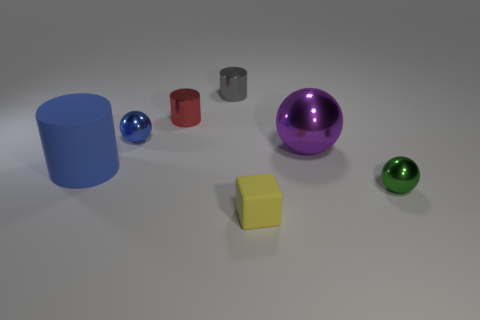Subtract all small red metallic cylinders. How many cylinders are left? 2 Subtract all cubes. How many objects are left? 6 Subtract all blue cylinders. How many cylinders are left? 2 Add 2 blue metallic things. How many objects exist? 9 Subtract 3 spheres. How many spheres are left? 0 Subtract all big purple metallic balls. Subtract all tiny green metallic things. How many objects are left? 5 Add 6 blue rubber cylinders. How many blue rubber cylinders are left? 7 Add 6 large shiny things. How many large shiny things exist? 7 Subtract 1 green spheres. How many objects are left? 6 Subtract all cyan cylinders. Subtract all gray blocks. How many cylinders are left? 3 